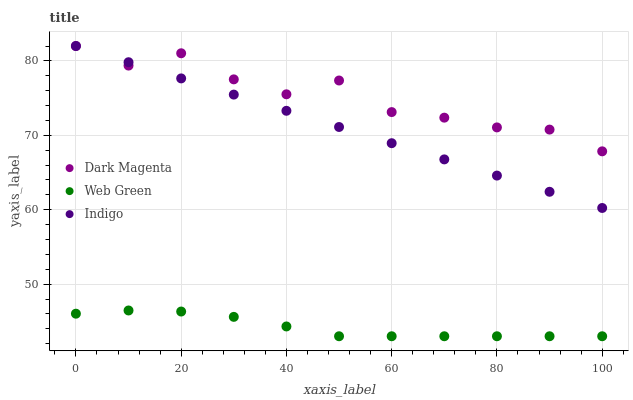Does Web Green have the minimum area under the curve?
Answer yes or no. Yes. Does Dark Magenta have the maximum area under the curve?
Answer yes or no. Yes. Does Dark Magenta have the minimum area under the curve?
Answer yes or no. No. Does Web Green have the maximum area under the curve?
Answer yes or no. No. Is Indigo the smoothest?
Answer yes or no. Yes. Is Dark Magenta the roughest?
Answer yes or no. Yes. Is Web Green the smoothest?
Answer yes or no. No. Is Web Green the roughest?
Answer yes or no. No. Does Web Green have the lowest value?
Answer yes or no. Yes. Does Dark Magenta have the lowest value?
Answer yes or no. No. Does Dark Magenta have the highest value?
Answer yes or no. Yes. Does Web Green have the highest value?
Answer yes or no. No. Is Web Green less than Dark Magenta?
Answer yes or no. Yes. Is Indigo greater than Web Green?
Answer yes or no. Yes. Does Dark Magenta intersect Indigo?
Answer yes or no. Yes. Is Dark Magenta less than Indigo?
Answer yes or no. No. Is Dark Magenta greater than Indigo?
Answer yes or no. No. Does Web Green intersect Dark Magenta?
Answer yes or no. No. 